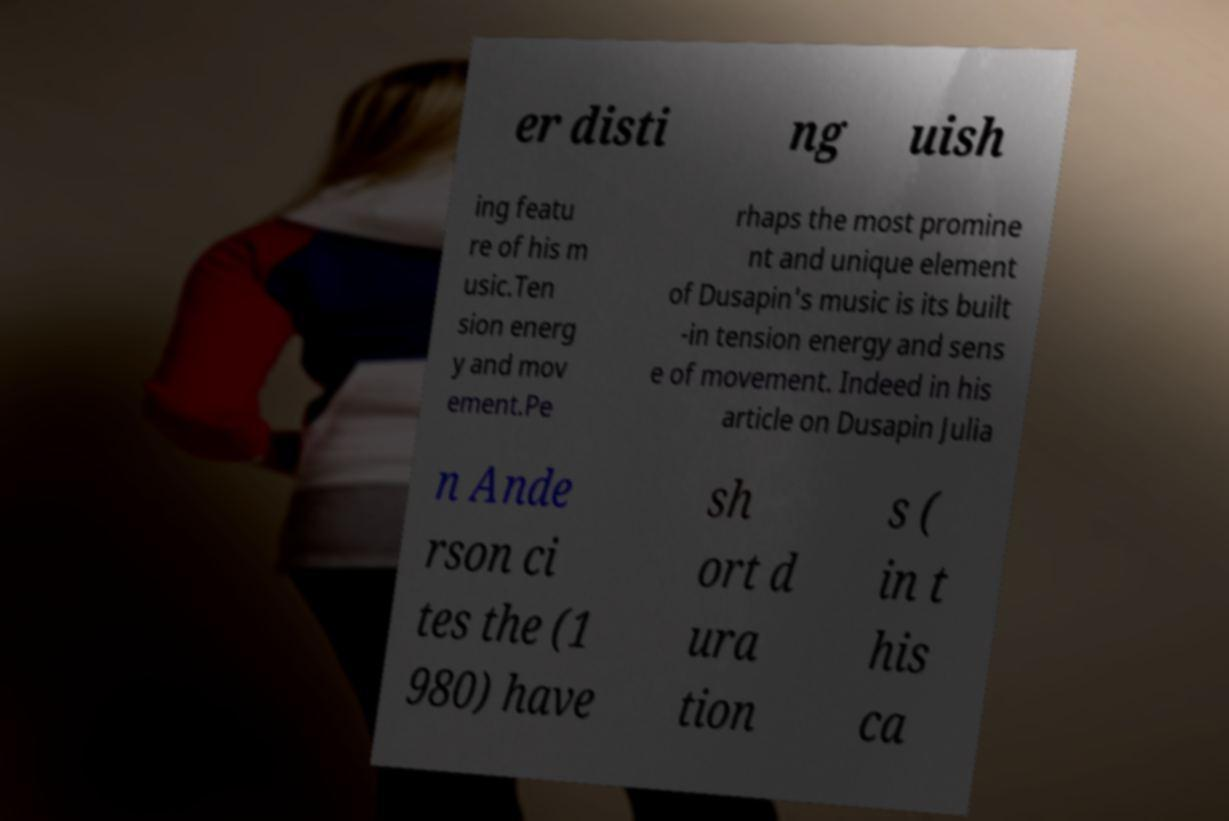Please read and relay the text visible in this image. What does it say? er disti ng uish ing featu re of his m usic.Ten sion energ y and mov ement.Pe rhaps the most promine nt and unique element of Dusapin's music is its built -in tension energy and sens e of movement. Indeed in his article on Dusapin Julia n Ande rson ci tes the (1 980) have sh ort d ura tion s ( in t his ca 